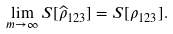Convert formula to latex. <formula><loc_0><loc_0><loc_500><loc_500>\lim _ { m \to \infty } S [ \widehat { \rho } _ { 1 2 3 } ] = S [ \rho _ { 1 2 3 } ] .</formula> 